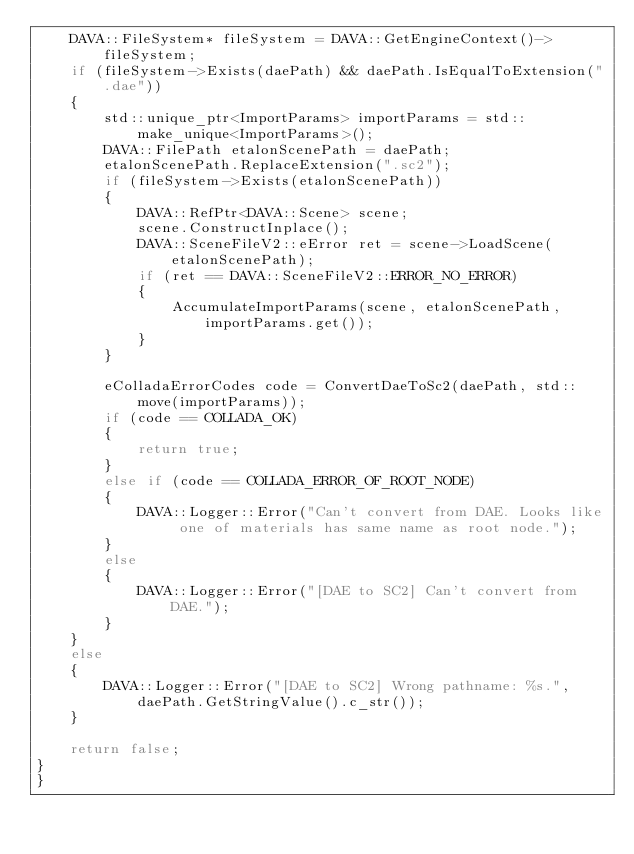Convert code to text. <code><loc_0><loc_0><loc_500><loc_500><_C++_>    DAVA::FileSystem* fileSystem = DAVA::GetEngineContext()->fileSystem;
    if (fileSystem->Exists(daePath) && daePath.IsEqualToExtension(".dae"))
    {
        std::unique_ptr<ImportParams> importParams = std::make_unique<ImportParams>();
        DAVA::FilePath etalonScenePath = daePath;
        etalonScenePath.ReplaceExtension(".sc2");
        if (fileSystem->Exists(etalonScenePath))
        {
            DAVA::RefPtr<DAVA::Scene> scene;
            scene.ConstructInplace();
            DAVA::SceneFileV2::eError ret = scene->LoadScene(etalonScenePath);
            if (ret == DAVA::SceneFileV2::ERROR_NO_ERROR)
            {
                AccumulateImportParams(scene, etalonScenePath, importParams.get());
            }
        }

        eColladaErrorCodes code = ConvertDaeToSc2(daePath, std::move(importParams));
        if (code == COLLADA_OK)
        {
            return true;
        }
        else if (code == COLLADA_ERROR_OF_ROOT_NODE)
        {
            DAVA::Logger::Error("Can't convert from DAE. Looks like one of materials has same name as root node.");
        }
        else
        {
            DAVA::Logger::Error("[DAE to SC2] Can't convert from DAE.");
        }
    }
    else
    {
        DAVA::Logger::Error("[DAE to SC2] Wrong pathname: %s.", daePath.GetStringValue().c_str());
    }

    return false;
}
}
</code> 